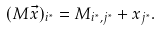Convert formula to latex. <formula><loc_0><loc_0><loc_500><loc_500>( M \vec { x } ) _ { i ^ { * } } = M _ { i ^ { * } , j ^ { * } } + x _ { j ^ { * } } .</formula> 